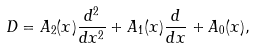Convert formula to latex. <formula><loc_0><loc_0><loc_500><loc_500>D = A _ { 2 } ( x ) \frac { d ^ { 2 } } { d x ^ { 2 } } + A _ { 1 } ( x ) \frac { d } { d x } + A _ { 0 } ( x ) ,</formula> 